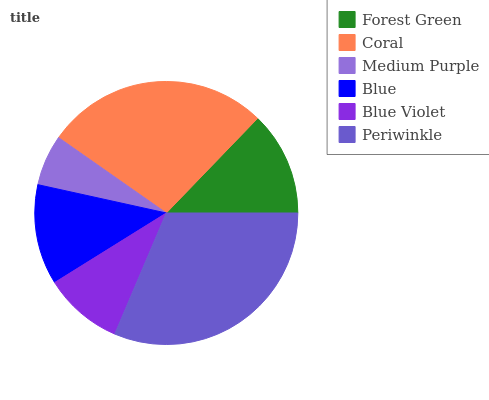Is Medium Purple the minimum?
Answer yes or no. Yes. Is Periwinkle the maximum?
Answer yes or no. Yes. Is Coral the minimum?
Answer yes or no. No. Is Coral the maximum?
Answer yes or no. No. Is Coral greater than Forest Green?
Answer yes or no. Yes. Is Forest Green less than Coral?
Answer yes or no. Yes. Is Forest Green greater than Coral?
Answer yes or no. No. Is Coral less than Forest Green?
Answer yes or no. No. Is Forest Green the high median?
Answer yes or no. Yes. Is Blue the low median?
Answer yes or no. Yes. Is Medium Purple the high median?
Answer yes or no. No. Is Periwinkle the low median?
Answer yes or no. No. 